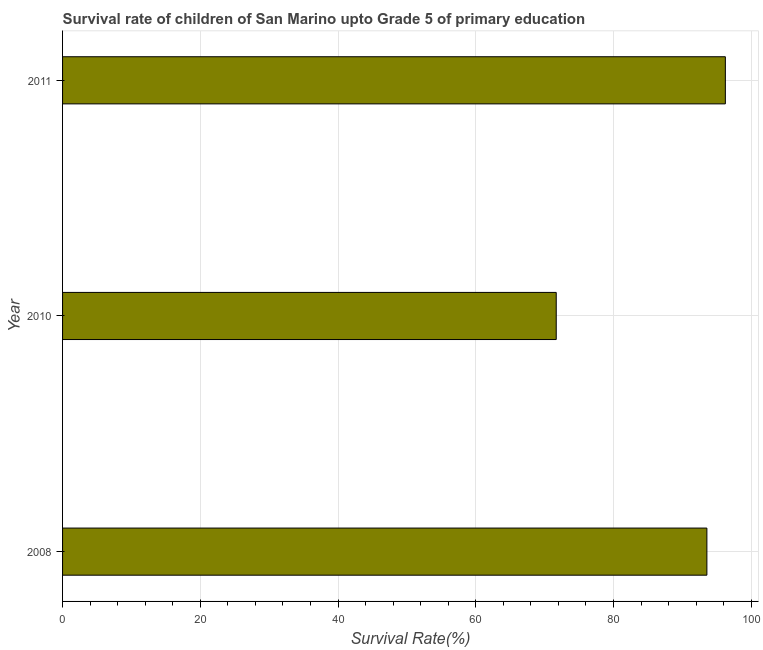What is the title of the graph?
Keep it short and to the point. Survival rate of children of San Marino upto Grade 5 of primary education. What is the label or title of the X-axis?
Your answer should be very brief. Survival Rate(%). What is the survival rate in 2011?
Your answer should be very brief. 96.25. Across all years, what is the maximum survival rate?
Provide a succinct answer. 96.25. Across all years, what is the minimum survival rate?
Offer a very short reply. 71.69. In which year was the survival rate minimum?
Your response must be concise. 2010. What is the sum of the survival rate?
Ensure brevity in your answer.  261.5. What is the difference between the survival rate in 2010 and 2011?
Ensure brevity in your answer.  -24.56. What is the average survival rate per year?
Make the answer very short. 87.17. What is the median survival rate?
Make the answer very short. 93.56. In how many years, is the survival rate greater than 32 %?
Your answer should be compact. 3. Is the survival rate in 2008 less than that in 2010?
Offer a terse response. No. Is the difference between the survival rate in 2010 and 2011 greater than the difference between any two years?
Your answer should be very brief. Yes. What is the difference between the highest and the second highest survival rate?
Give a very brief answer. 2.68. What is the difference between the highest and the lowest survival rate?
Your answer should be very brief. 24.56. Are all the bars in the graph horizontal?
Your answer should be compact. Yes. What is the difference between two consecutive major ticks on the X-axis?
Provide a short and direct response. 20. Are the values on the major ticks of X-axis written in scientific E-notation?
Keep it short and to the point. No. What is the Survival Rate(%) in 2008?
Give a very brief answer. 93.56. What is the Survival Rate(%) in 2010?
Your response must be concise. 71.69. What is the Survival Rate(%) of 2011?
Your response must be concise. 96.25. What is the difference between the Survival Rate(%) in 2008 and 2010?
Your answer should be compact. 21.88. What is the difference between the Survival Rate(%) in 2008 and 2011?
Ensure brevity in your answer.  -2.68. What is the difference between the Survival Rate(%) in 2010 and 2011?
Offer a very short reply. -24.56. What is the ratio of the Survival Rate(%) in 2008 to that in 2010?
Give a very brief answer. 1.3. What is the ratio of the Survival Rate(%) in 2010 to that in 2011?
Give a very brief answer. 0.74. 